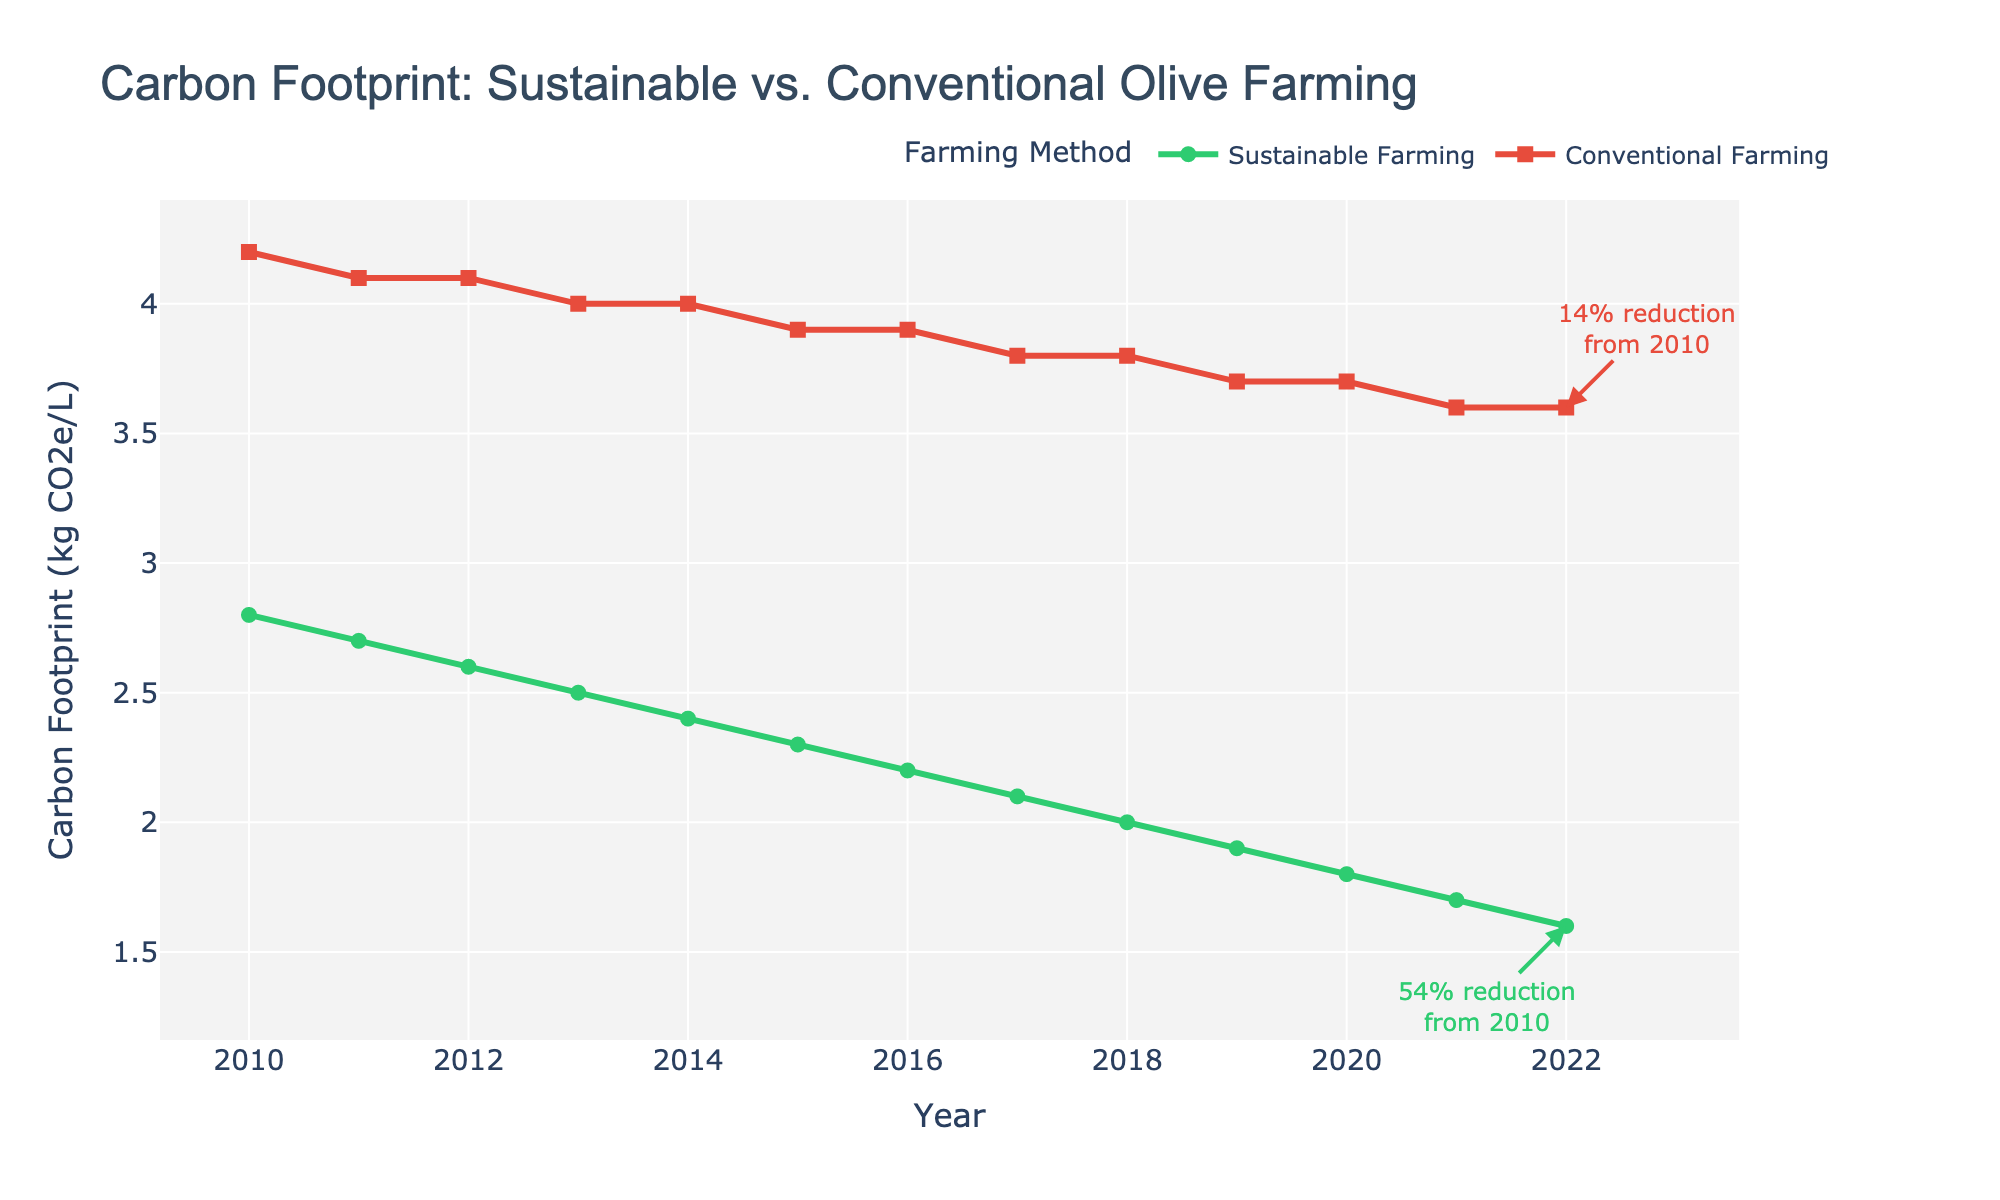What is the trend in carbon footprint for sustainable farming from 2010 to 2022? The line representing sustainable farming shows a continuous decrease in carbon footprint over the years from 2010 to 2022. The values decrease from 2.8 kg CO2e/L in 2010 to 1.6 kg CO2e/L in 2022.
Answer: Continuous decrease How do the carbon footprints of sustainable and conventional farming compare in 2022? In 2022, the carbon footprint for sustainable farming is 1.6 kg CO2e/L, while for conventional farming, it is 3.6 kg CO2e/L. This shows that sustainable farming has a lower carbon footprint compared to conventional farming in 2022.
Answer: Sustainable farming is lower What is the percentage reduction in carbon footprint for sustainable farming from 2010 to 2022? The initial value in 2010 is 2.8 kg CO2e/L and the final value in 2022 is 1.6 kg CO2e/L. The reduction is thus (2.8 - 1.6) / 2.8 * 100 ≈ 42.86% reduction from 2010 to 2022.
Answer: ~43% Which farming method shows a greater reduction in carbon footprint over the whole period? Sustainable farming decreases from 2.8 kg CO2e/L to 1.6 kg CO2e/L, a reduction of 1.2 kg CO2e/L. Conventional farming decreases from 4.2 kg CO2e/L to 3.6 kg CO2e/L, a reduction of 0.6 kg CO2e/L. Therefore, sustainable farming shows greater reduction.
Answer: Sustainable farming What was the carbon footprint for conventional farming in 2015? By looking at the point for the year 2015 on the red line representing conventional farming, the carbon footprint was 3.9 kg CO2e/L.
Answer: 3.9 kg CO2e/L What is the difference in carbon footprints between the two farming methods in 2013? The value for sustainable farming in 2013 is 2.5 kg CO2e/L and for conventional farming it is 4.0 kg CO2e/L. The difference is 4.0 - 2.5 = 1.5 kg CO2e/L.
Answer: 1.5 kg CO2e/L How did the carbon footprint for conventional farming change from 2011 to 2012? From the graph for conventional farming, the carbon footprint remains constant at 4.1 kg CO2e/L in both 2011 and 2012.
Answer: Stayed constant Which farming method experienced a consistent year-over-year decrease in carbon footprint? By examining the lines, sustainable farming shows a consistent decrease in carbon footprint each year from 2010 to 2022.
Answer: Sustainable farming By what percentage did the carbon footprint of conventional farming decrease from 2010 to 2019? The initial value in 2010 is 4.2 kg CO2e/L and the value in 2019 is 3.7 kg CO2e/L. The reduction is (4.2 - 3.7) / 4.2 * 100 ≈ 11.9%.
Answer: ~12% Which year shows the biggest one-year drop in carbon footprint for sustainable farming? The largest one-year drop occurs between 2014 (2.4 kg CO2e/L) and 2015 (2.3 kg CO2e/L), which is a drop of 0.1 kg CO2e/L.
Answer: 2014 to 2015 